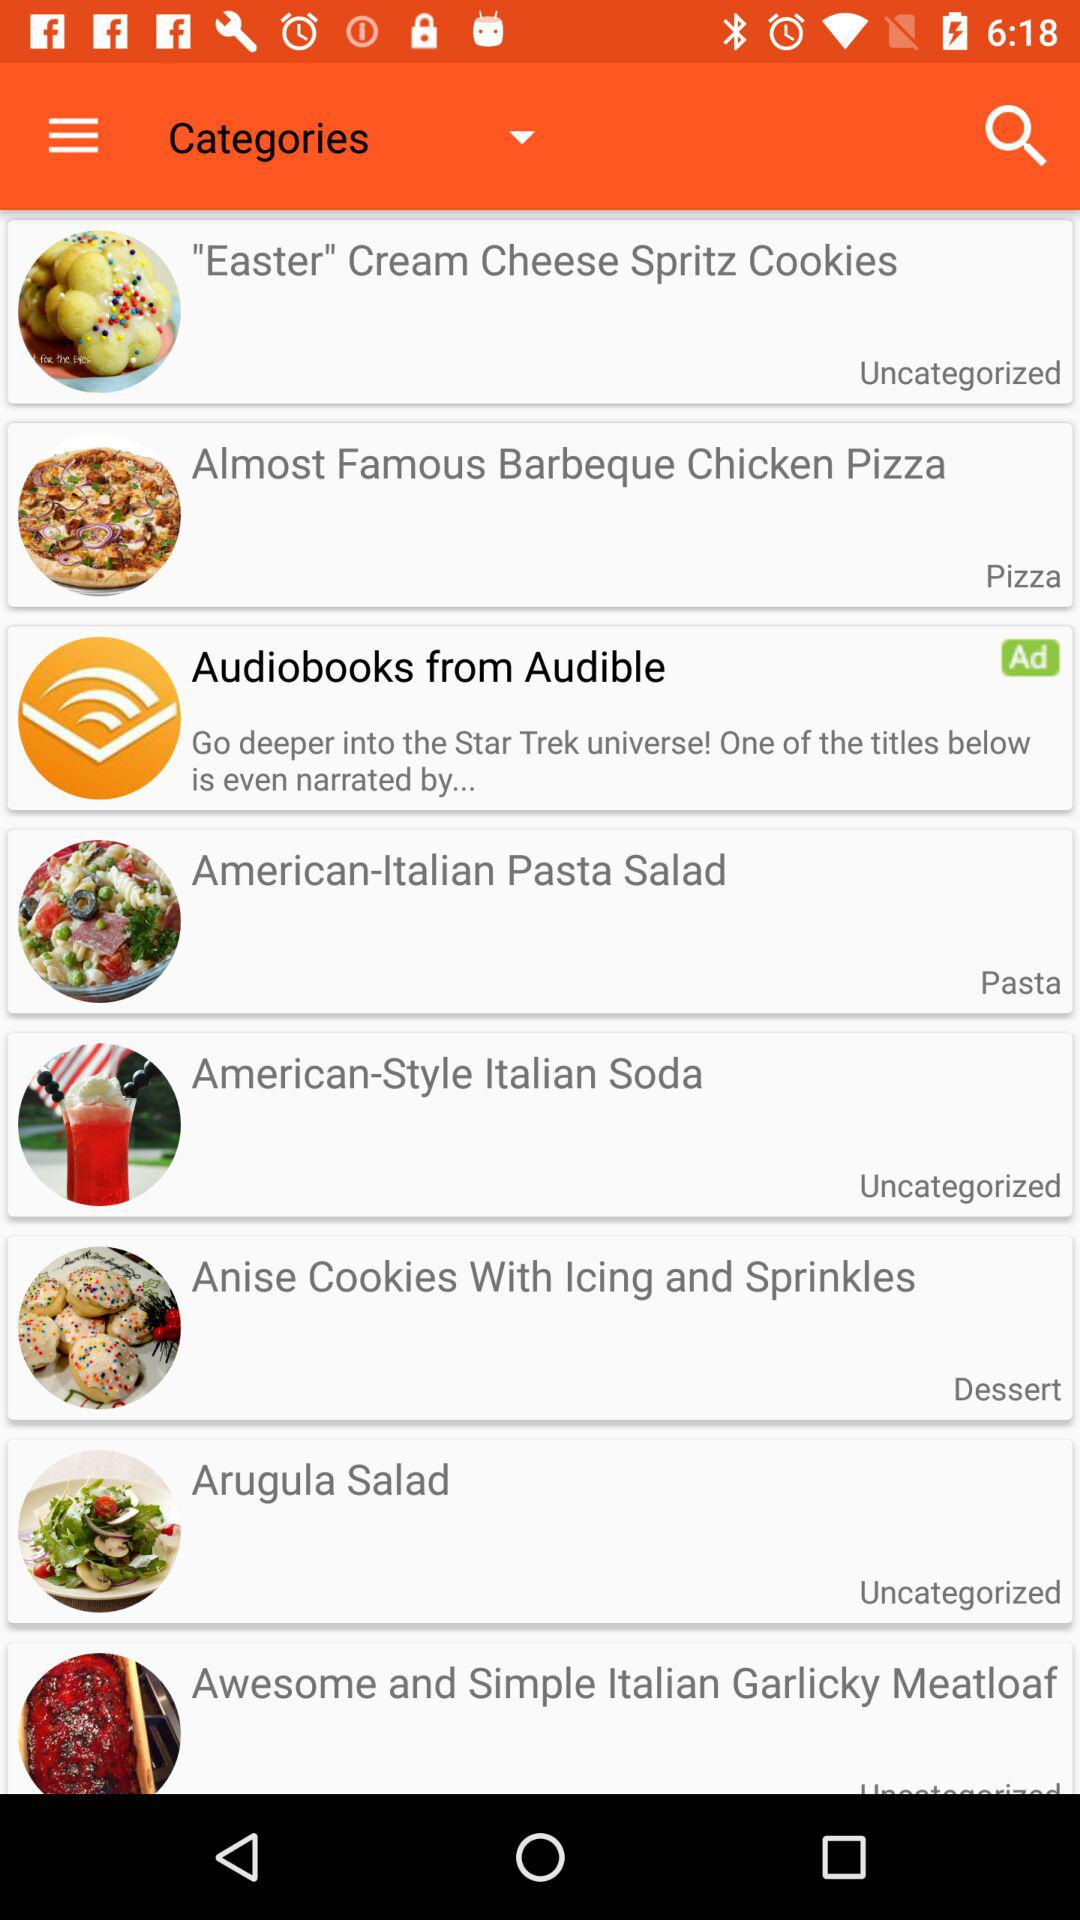Which food item is in the "Dessert" category? The food item that is in the "Dessert" category is "Anise Cookies With Icing and Sprinkles". 